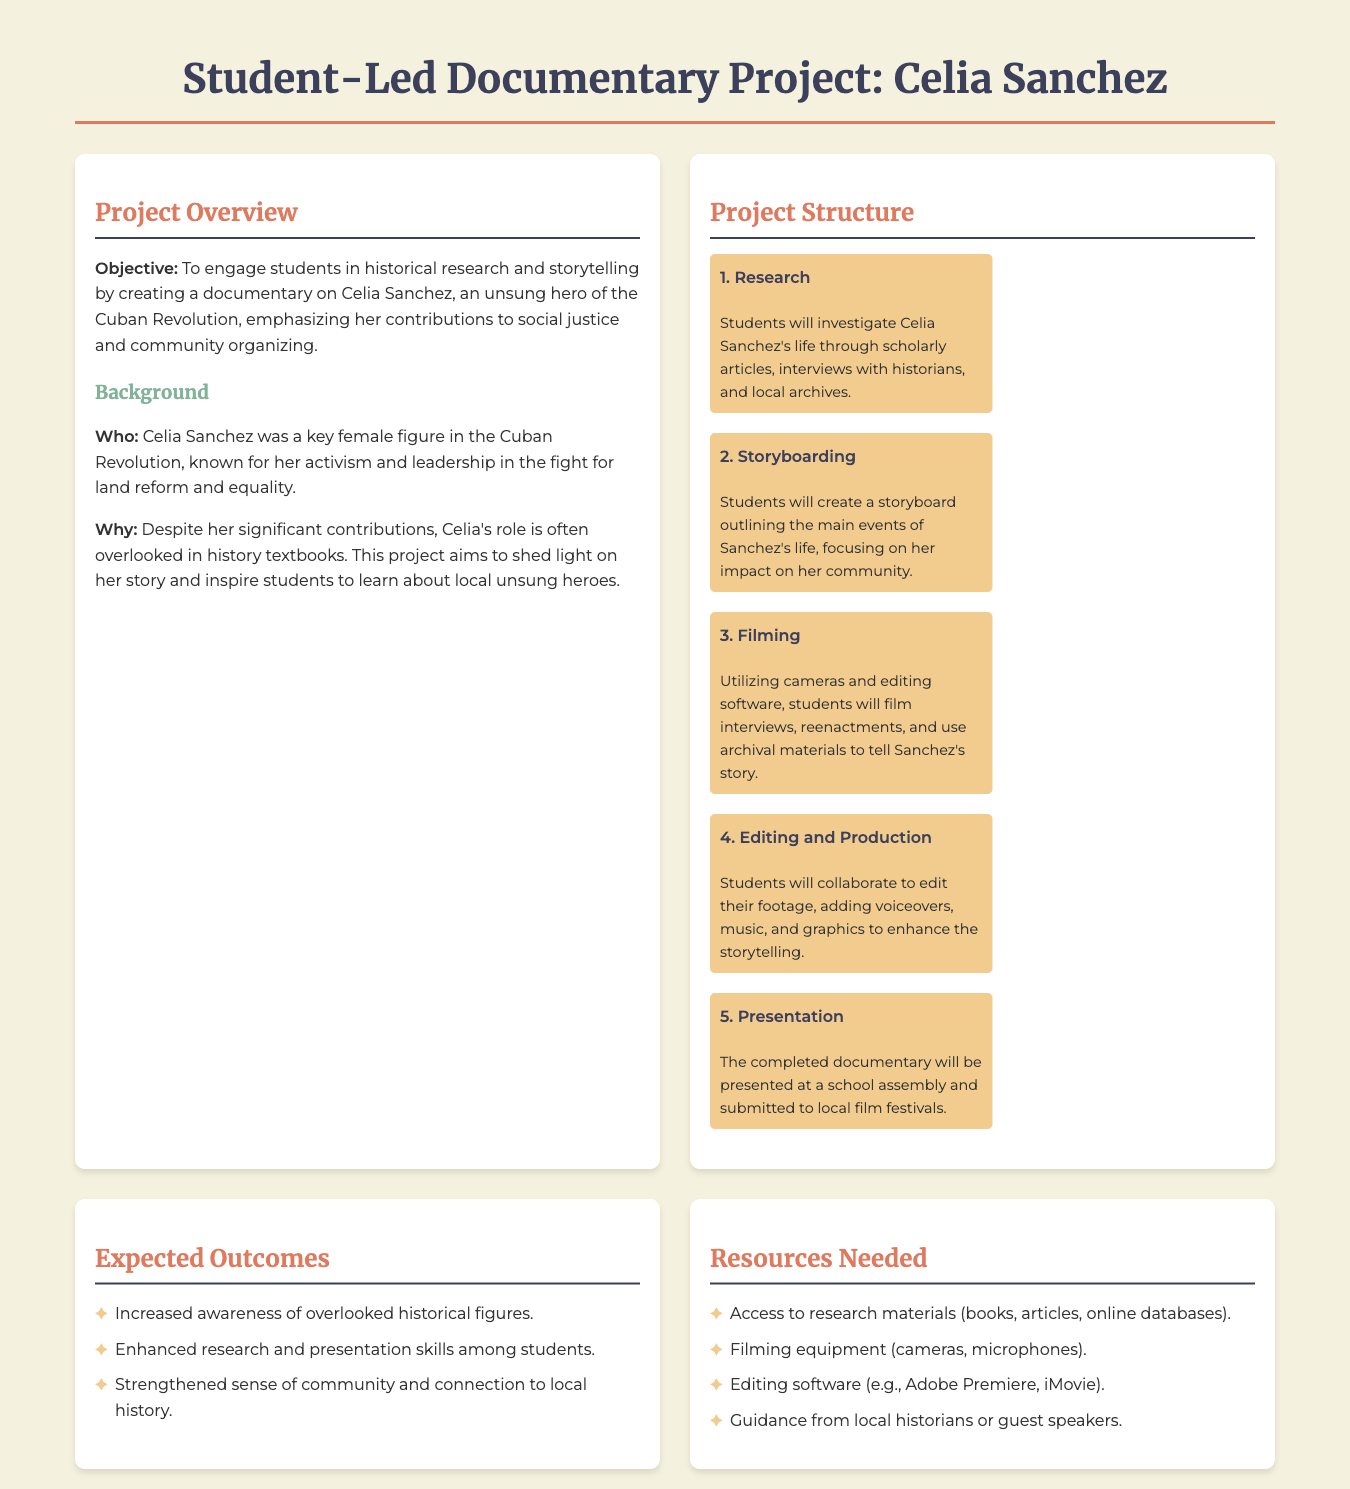what is the title of the project? The title can be found at the top of the document, which specifies the focus of the student-led effort.
Answer: Student-Led Documentary Project: Celia Sanchez who is the unsung hero featured in the documentary? The document explicitly states the name of the historical figure that students will focus on for their project.
Answer: Celia Sanchez what is the main objective of the project? The document outlines the specific aim behind creating the documentary, emphasizing engagement in historical activities.
Answer: To engage students in historical research and storytelling how many phases are there in the project structure? The document lists the phases involved in executing the project, providing clarity on the step-by-step process.
Answer: 5 name one expected outcome of the project. The document lists a variety of expected results, focusing on student learning and community awareness.
Answer: Increased awareness of overlooked historical figures what type of equipment is needed for filming? The document includes a section listing specific resources required to conduct the project effectively.
Answer: Cameras which skills will be enhanced among students? The document highlights the capabilities that students will develop through participation in the project.
Answer: Research and presentation skills who will guide the students during the project? The document notes the involvement of local experts who will support the students' research and learning process.
Answer: Local historians or guest speakers what will happen during the presentation phase? The document specifies what students will do once their documentary is completed, providing details on its public showing.
Answer: Presented at a school assembly and submitted to local film festivals 